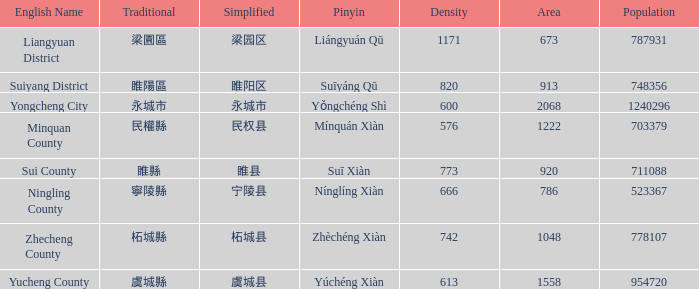What is the traditional form for 宁陵县? 寧陵縣. 